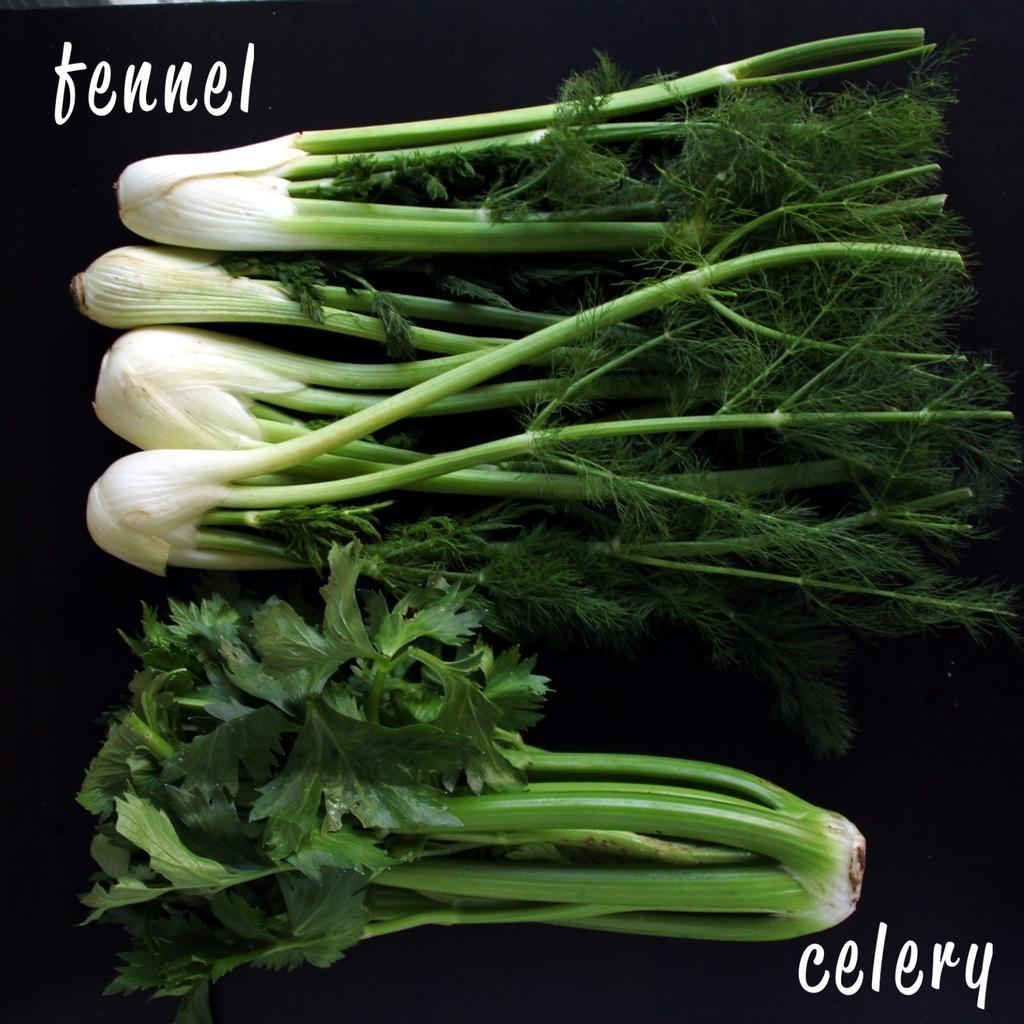How would you summarize this image in a sentence or two? In this picture we can see some radishes here, we can see a dark background, there is some text here. 